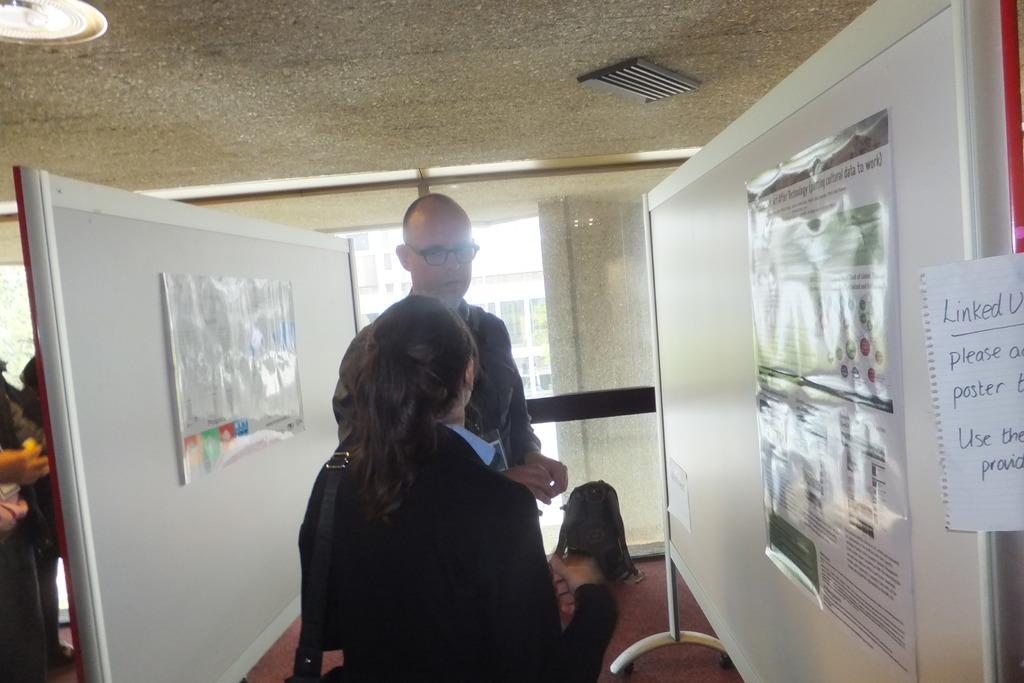How would you summarize this image in a sentence or two? In this picture we can see a women wearing a black coat and bag on the shoulder discussing something with man beside her. Behind we can see white wall and white chart stick on it. On the right side we can see a white panel board with some chart stick on it 